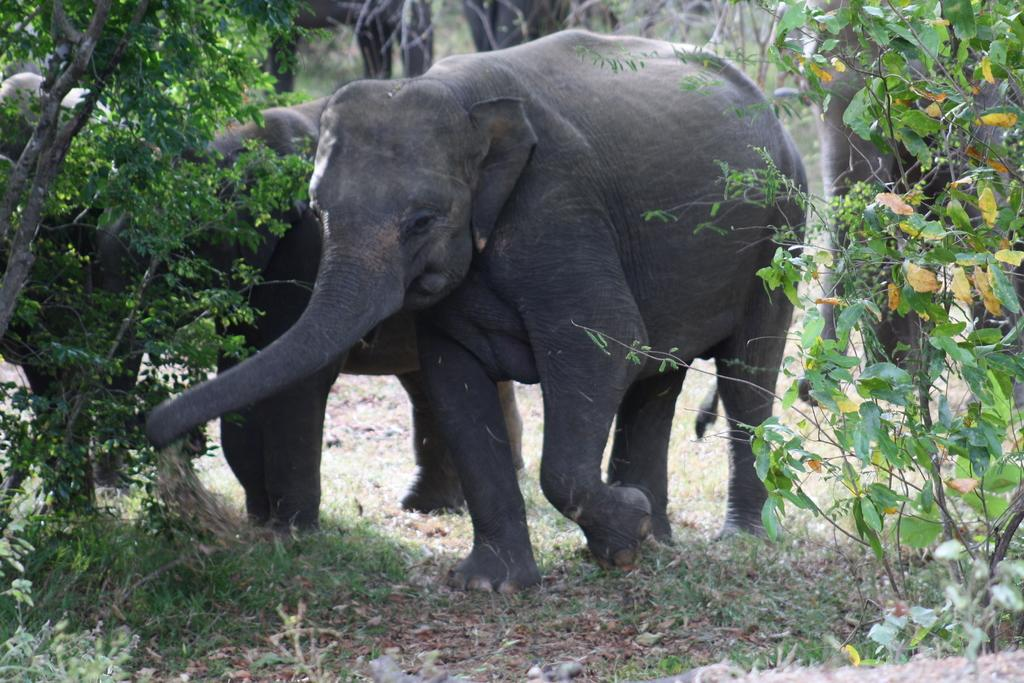What animals are present in the image? There are elephants in the image. Where are the elephants located? The elephants are on the ground. What can be seen in the background of the image? There are trees visible in the background of the image. What type of guide is helping the elephants in the image? There is no guide present in the image; it only features elephants on the ground with trees in the background. 